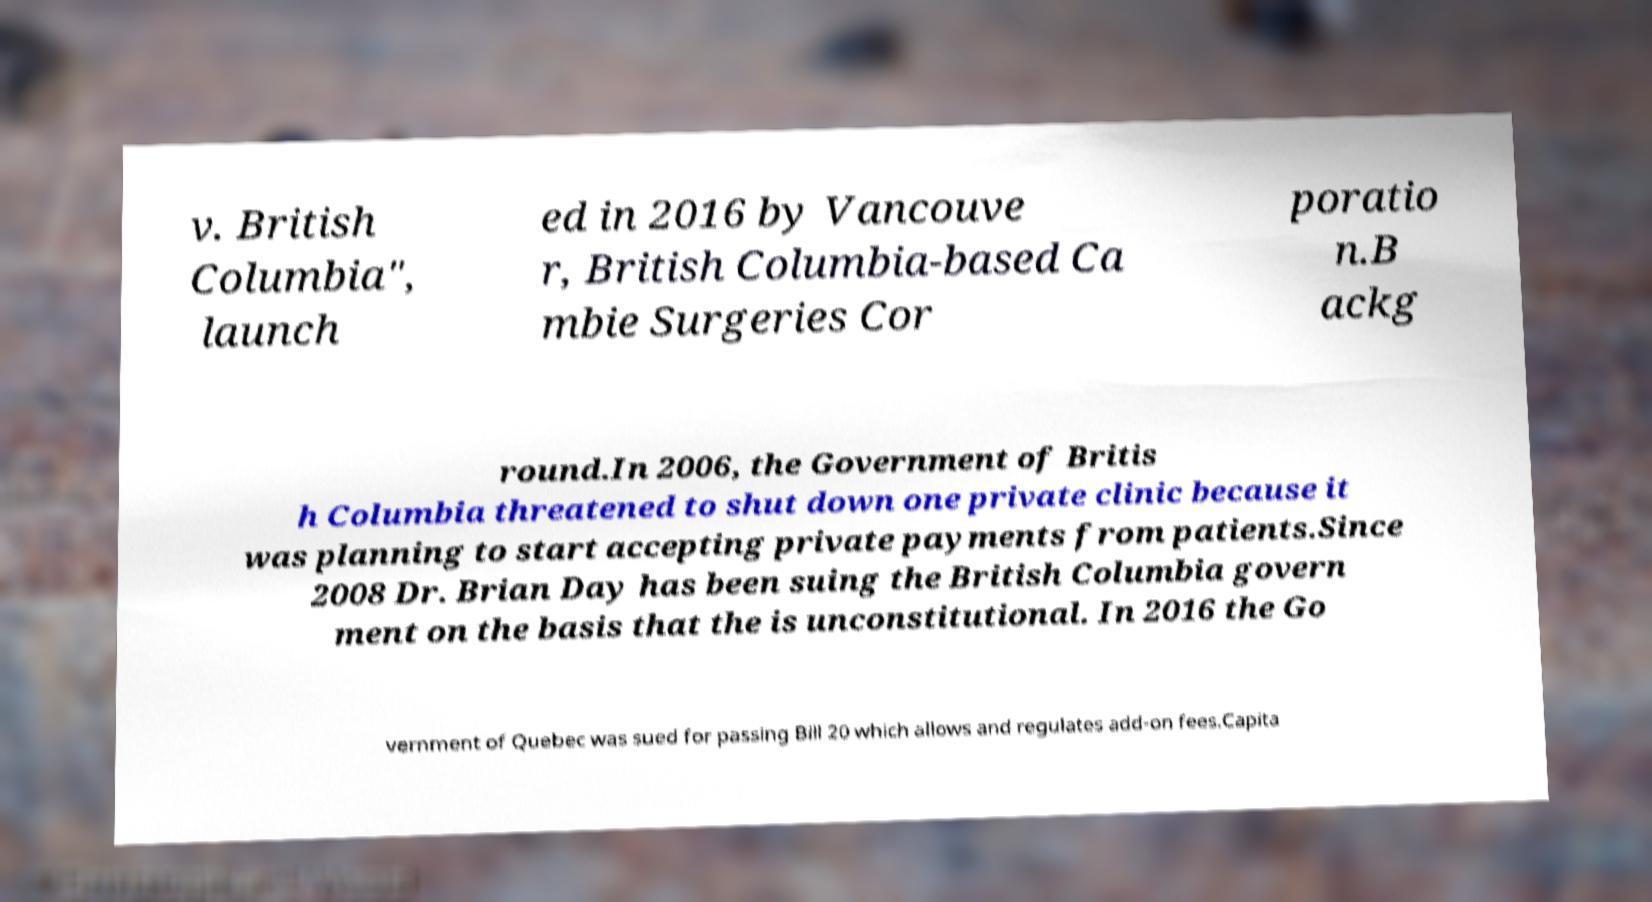What messages or text are displayed in this image? I need them in a readable, typed format. v. British Columbia", launch ed in 2016 by Vancouve r, British Columbia-based Ca mbie Surgeries Cor poratio n.B ackg round.In 2006, the Government of Britis h Columbia threatened to shut down one private clinic because it was planning to start accepting private payments from patients.Since 2008 Dr. Brian Day has been suing the British Columbia govern ment on the basis that the is unconstitutional. In 2016 the Go vernment of Quebec was sued for passing Bill 20 which allows and regulates add-on fees.Capita 